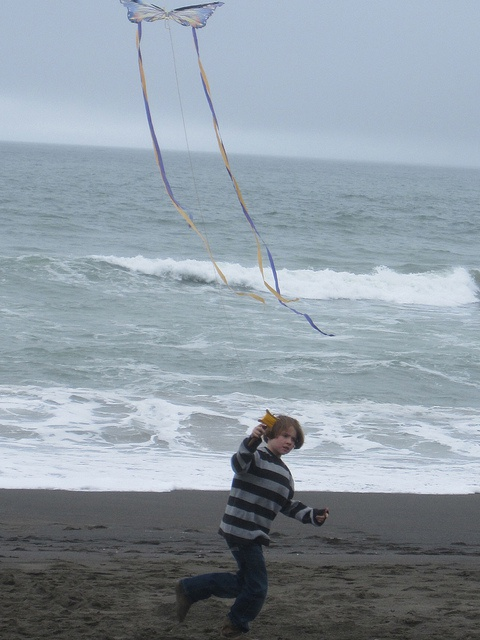Describe the objects in this image and their specific colors. I can see people in darkgray, black, and gray tones and kite in darkgray, gray, and tan tones in this image. 